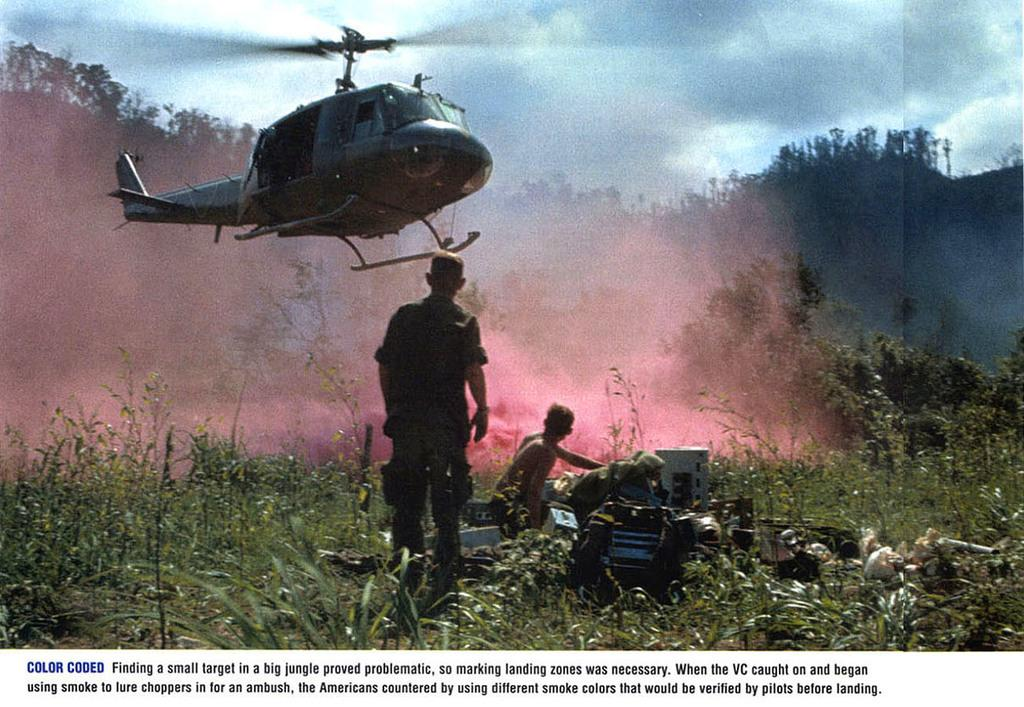<image>
Offer a succinct explanation of the picture presented. a helicopter landing in a field in front of two soldiers with words Color Coded in the text 